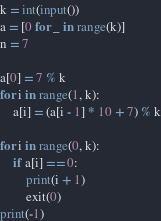<code> <loc_0><loc_0><loc_500><loc_500><_Python_>k = int(input())
a = [0 for _ in range(k)]
n = 7

a[0] = 7 % k
for i in range(1, k):
    a[i] = (a[i - 1] * 10 + 7) % k

for i in range(0, k):
    if a[i] == 0:
        print(i + 1)
        exit(0)
print(-1)</code> 